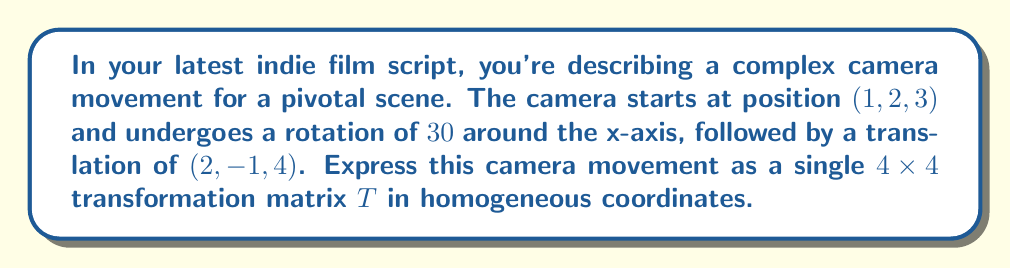Can you solve this math problem? Let's break this down step-by-step:

1) First, we need to represent the rotation around the x-axis. The rotation matrix for a counterclockwise rotation of $\theta$ around the x-axis is:

   $$R_x(\theta) = \begin{pmatrix}
   1 & 0 & 0 & 0 \\
   0 & \cos\theta & -\sin\theta & 0 \\
   0 & \sin\theta & \cos\theta & 0 \\
   0 & 0 & 0 & 1
   \end{pmatrix}$$

2) For $\theta = 30°$, we have:

   $$R_x(30°) = \begin{pmatrix}
   1 & 0 & 0 & 0 \\
   0 & \frac{\sqrt{3}}{2} & -\frac{1}{2} & 0 \\
   0 & \frac{1}{2} & \frac{\sqrt{3}}{2} & 0 \\
   0 & 0 & 0 & 1
   \end{pmatrix}$$

3) Next, we need to represent the translation. In homogeneous coordinates, a translation by vector $(t_x, t_y, t_z)$ is represented as:

   $$T(t_x, t_y, t_z) = \begin{pmatrix}
   1 & 0 & 0 & t_x \\
   0 & 1 & 0 & t_y \\
   0 & 0 & 1 & t_z \\
   0 & 0 & 0 & 1
   \end{pmatrix}$$

4) For the translation $(2, -1, 4)$, we have:

   $$T(2, -1, 4) = \begin{pmatrix}
   1 & 0 & 0 & 2 \\
   0 & 1 & 0 & -1 \\
   0 & 0 & 1 & 4 \\
   0 & 0 & 0 & 1
   \end{pmatrix}$$

5) The complete transformation is the product of these matrices, with the rotation applied first:

   $$T = T(2, -1, 4) \cdot R_x(30°)$$

6) Multiplying these matrices:

   $$T = \begin{pmatrix}
   1 & 0 & 0 & 2 \\
   0 & \frac{\sqrt{3}}{2} & -\frac{1}{2} & -1 \\
   0 & \frac{1}{2} & \frac{\sqrt{3}}{2} & 4 \\
   0 & 0 & 0 & 1
   \end{pmatrix}$$

This matrix $T$ represents the complete camera movement in a single transformation.
Answer: $$T = \begin{pmatrix}
1 & 0 & 0 & 2 \\
0 & \frac{\sqrt{3}}{2} & -\frac{1}{2} & -1 \\
0 & \frac{1}{2} & \frac{\sqrt{3}}{2} & 4 \\
0 & 0 & 0 & 1
\end{pmatrix}$$ 